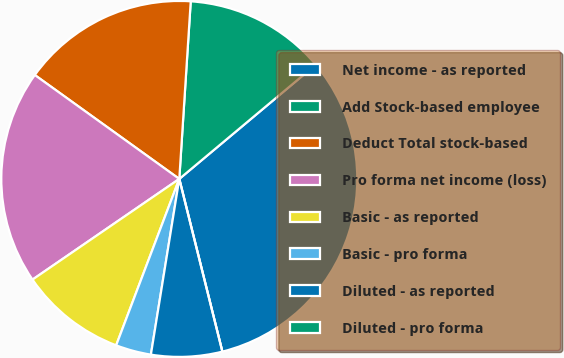<chart> <loc_0><loc_0><loc_500><loc_500><pie_chart><fcel>Net income - as reported<fcel>Add Stock-based employee<fcel>Deduct Total stock-based<fcel>Pro forma net income (loss)<fcel>Basic - as reported<fcel>Basic - pro forma<fcel>Diluted - as reported<fcel>Diluted - pro forma<nl><fcel>32.2%<fcel>12.88%<fcel>16.1%<fcel>19.49%<fcel>9.66%<fcel>3.22%<fcel>6.44%<fcel>0.0%<nl></chart> 